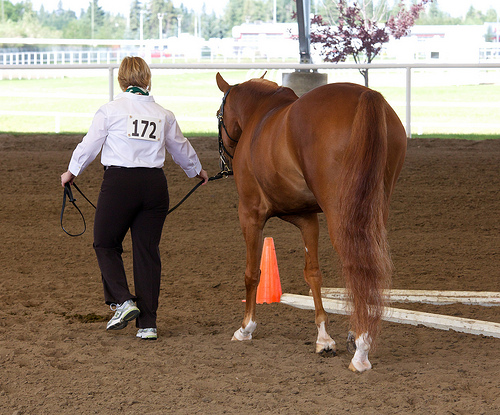<image>
Can you confirm if the cone is behind the horse? No. The cone is not behind the horse. From this viewpoint, the cone appears to be positioned elsewhere in the scene. 